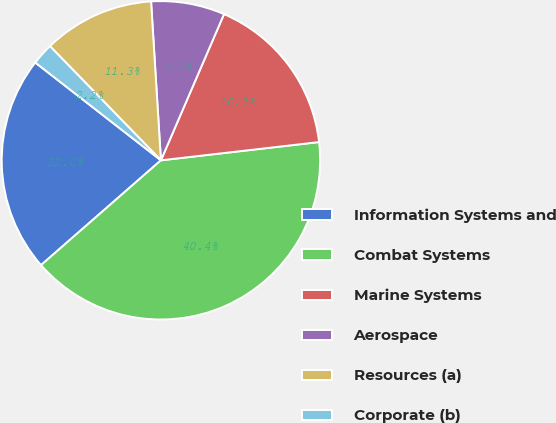Convert chart. <chart><loc_0><loc_0><loc_500><loc_500><pie_chart><fcel>Information Systems and<fcel>Combat Systems<fcel>Marine Systems<fcel>Aerospace<fcel>Resources (a)<fcel>Corporate (b)<nl><fcel>21.96%<fcel>40.4%<fcel>16.69%<fcel>7.47%<fcel>11.29%<fcel>2.2%<nl></chart> 